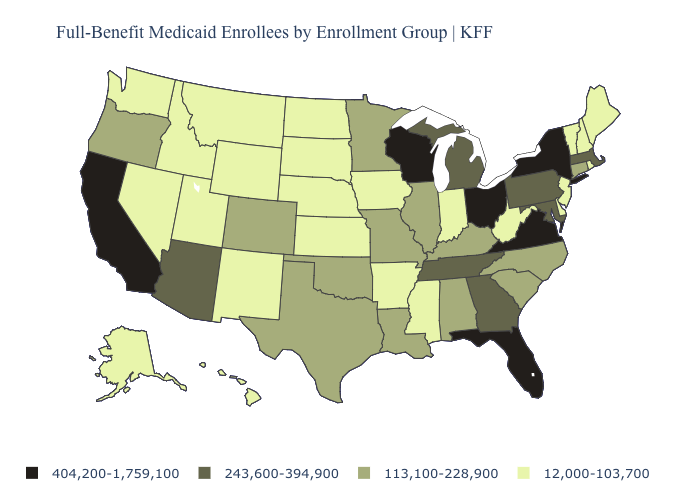Among the states that border North Dakota , does South Dakota have the highest value?
Be succinct. No. What is the value of Kentucky?
Give a very brief answer. 113,100-228,900. Among the states that border Utah , which have the highest value?
Be succinct. Arizona. What is the value of Pennsylvania?
Write a very short answer. 243,600-394,900. What is the value of Delaware?
Write a very short answer. 12,000-103,700. What is the value of Colorado?
Give a very brief answer. 113,100-228,900. Which states have the lowest value in the USA?
Give a very brief answer. Alaska, Arkansas, Delaware, Hawaii, Idaho, Indiana, Iowa, Kansas, Maine, Mississippi, Montana, Nebraska, Nevada, New Hampshire, New Jersey, New Mexico, North Dakota, Rhode Island, South Dakota, Utah, Vermont, Washington, West Virginia, Wyoming. What is the value of Virginia?
Be succinct. 404,200-1,759,100. Name the states that have a value in the range 113,100-228,900?
Short answer required. Alabama, Colorado, Connecticut, Illinois, Kentucky, Louisiana, Minnesota, Missouri, North Carolina, Oklahoma, Oregon, South Carolina, Texas. What is the value of Mississippi?
Keep it brief. 12,000-103,700. Among the states that border Illinois , which have the highest value?
Short answer required. Wisconsin. Is the legend a continuous bar?
Keep it brief. No. What is the lowest value in the Northeast?
Short answer required. 12,000-103,700. Does Rhode Island have a lower value than Florida?
Concise answer only. Yes. Which states have the lowest value in the South?
Quick response, please. Arkansas, Delaware, Mississippi, West Virginia. 